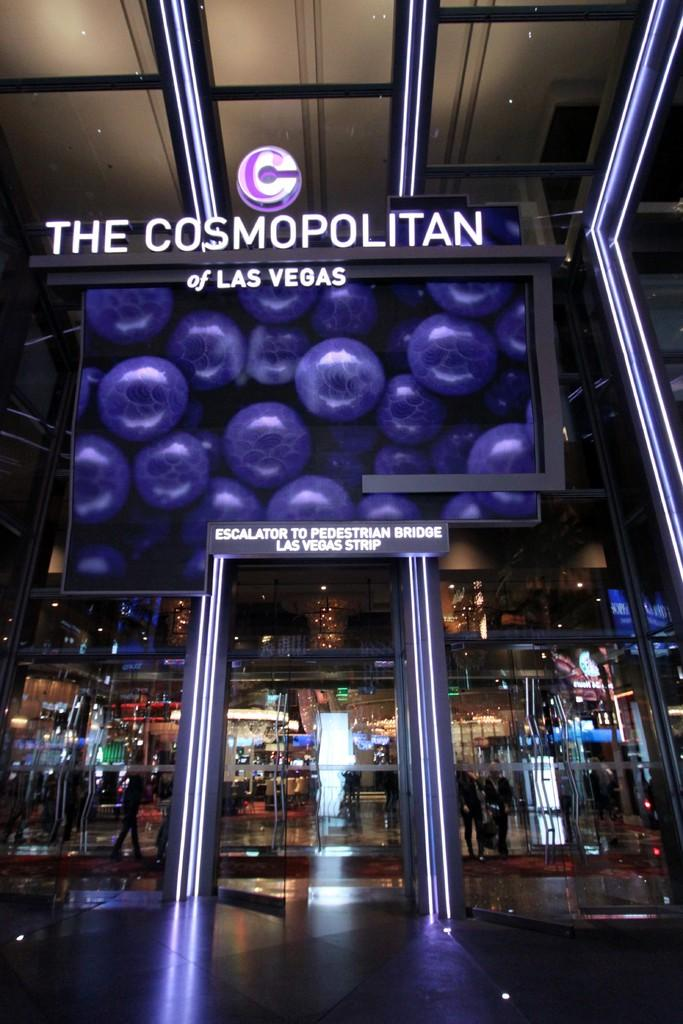<image>
Relay a brief, clear account of the picture shown. The glass elevator to the pedestrian bridge inside of the Cosmopolitan hotel in Las Vegas is shown. 